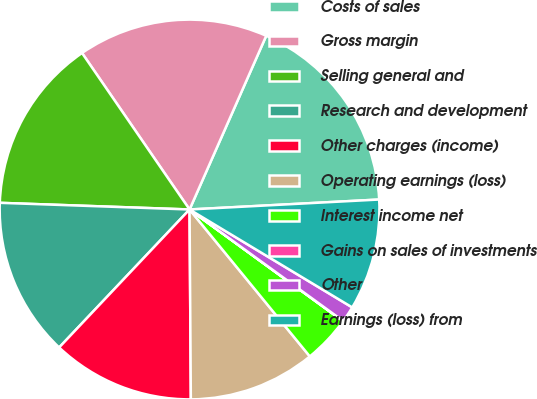<chart> <loc_0><loc_0><loc_500><loc_500><pie_chart><fcel>Costs of sales<fcel>Gross margin<fcel>Selling general and<fcel>Research and development<fcel>Other charges (income)<fcel>Operating earnings (loss)<fcel>Interest income net<fcel>Gains on sales of investments<fcel>Other<fcel>Earnings (loss) from<nl><fcel>17.55%<fcel>16.2%<fcel>14.86%<fcel>13.51%<fcel>12.16%<fcel>10.81%<fcel>4.07%<fcel>0.02%<fcel>1.37%<fcel>9.46%<nl></chart> 